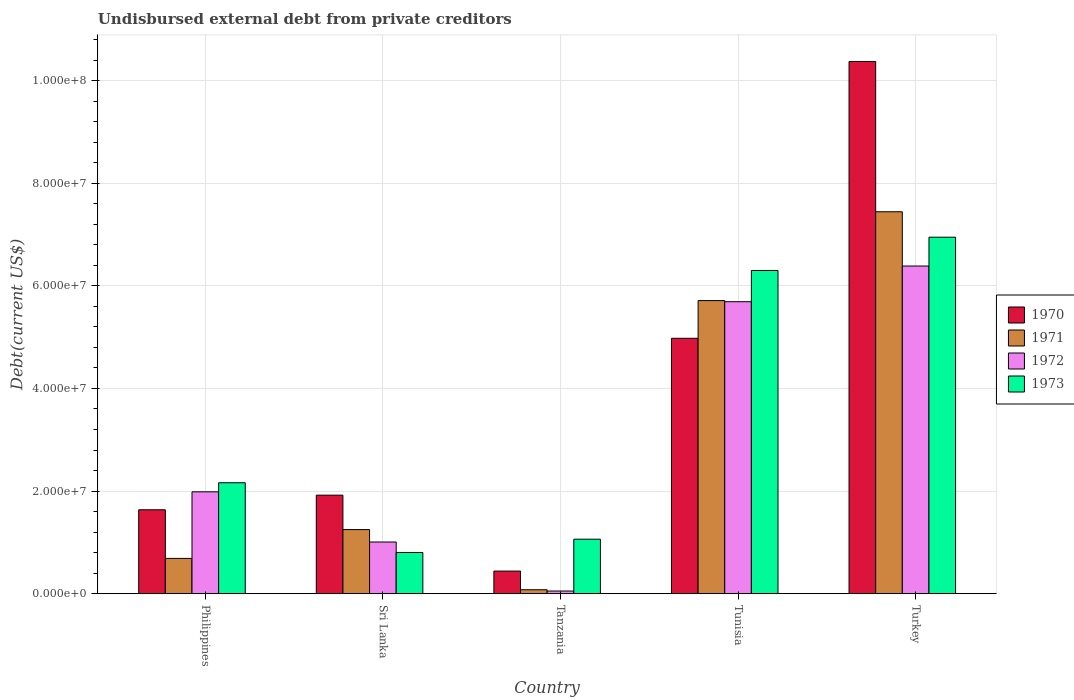How many different coloured bars are there?
Offer a terse response. 4. How many groups of bars are there?
Provide a short and direct response. 5. Are the number of bars per tick equal to the number of legend labels?
Your answer should be compact. Yes. What is the label of the 5th group of bars from the left?
Keep it short and to the point. Turkey. What is the total debt in 1971 in Tunisia?
Provide a succinct answer. 5.71e+07. Across all countries, what is the maximum total debt in 1971?
Your response must be concise. 7.44e+07. Across all countries, what is the minimum total debt in 1972?
Give a very brief answer. 5.15e+05. In which country was the total debt in 1973 minimum?
Your response must be concise. Sri Lanka. What is the total total debt in 1972 in the graph?
Keep it short and to the point. 1.51e+08. What is the difference between the total debt in 1972 in Tanzania and that in Turkey?
Ensure brevity in your answer.  -6.34e+07. What is the difference between the total debt in 1972 in Turkey and the total debt in 1971 in Sri Lanka?
Ensure brevity in your answer.  5.14e+07. What is the average total debt in 1972 per country?
Provide a short and direct response. 3.02e+07. What is the difference between the total debt of/in 1972 and total debt of/in 1970 in Tunisia?
Offer a very short reply. 7.13e+06. What is the ratio of the total debt in 1973 in Tanzania to that in Tunisia?
Make the answer very short. 0.17. Is the total debt in 1971 in Philippines less than that in Turkey?
Provide a succinct answer. Yes. Is the difference between the total debt in 1972 in Philippines and Sri Lanka greater than the difference between the total debt in 1970 in Philippines and Sri Lanka?
Your answer should be very brief. Yes. What is the difference between the highest and the second highest total debt in 1970?
Provide a succinct answer. 5.40e+07. What is the difference between the highest and the lowest total debt in 1971?
Provide a short and direct response. 7.37e+07. Is the sum of the total debt in 1972 in Sri Lanka and Tanzania greater than the maximum total debt in 1973 across all countries?
Make the answer very short. No. Is it the case that in every country, the sum of the total debt in 1973 and total debt in 1971 is greater than the sum of total debt in 1970 and total debt in 1972?
Ensure brevity in your answer.  No. What does the 1st bar from the left in Philippines represents?
Give a very brief answer. 1970. What does the 3rd bar from the right in Turkey represents?
Keep it short and to the point. 1971. Is it the case that in every country, the sum of the total debt in 1971 and total debt in 1970 is greater than the total debt in 1972?
Provide a short and direct response. Yes. Are the values on the major ticks of Y-axis written in scientific E-notation?
Provide a short and direct response. Yes. Does the graph contain grids?
Keep it short and to the point. Yes. How many legend labels are there?
Ensure brevity in your answer.  4. What is the title of the graph?
Offer a terse response. Undisbursed external debt from private creditors. What is the label or title of the Y-axis?
Your answer should be compact. Debt(current US$). What is the Debt(current US$) in 1970 in Philippines?
Your response must be concise. 1.64e+07. What is the Debt(current US$) in 1971 in Philippines?
Make the answer very short. 6.87e+06. What is the Debt(current US$) in 1972 in Philippines?
Your response must be concise. 1.99e+07. What is the Debt(current US$) of 1973 in Philippines?
Offer a very short reply. 2.16e+07. What is the Debt(current US$) in 1970 in Sri Lanka?
Ensure brevity in your answer.  1.92e+07. What is the Debt(current US$) in 1971 in Sri Lanka?
Offer a very short reply. 1.25e+07. What is the Debt(current US$) of 1972 in Sri Lanka?
Your response must be concise. 1.01e+07. What is the Debt(current US$) of 1973 in Sri Lanka?
Your response must be concise. 8.03e+06. What is the Debt(current US$) of 1970 in Tanzania?
Your response must be concise. 4.40e+06. What is the Debt(current US$) of 1971 in Tanzania?
Give a very brief answer. 7.65e+05. What is the Debt(current US$) of 1972 in Tanzania?
Provide a short and direct response. 5.15e+05. What is the Debt(current US$) of 1973 in Tanzania?
Give a very brief answer. 1.06e+07. What is the Debt(current US$) of 1970 in Tunisia?
Provide a short and direct response. 4.98e+07. What is the Debt(current US$) of 1971 in Tunisia?
Provide a succinct answer. 5.71e+07. What is the Debt(current US$) in 1972 in Tunisia?
Your answer should be very brief. 5.69e+07. What is the Debt(current US$) in 1973 in Tunisia?
Your answer should be compact. 6.30e+07. What is the Debt(current US$) of 1970 in Turkey?
Your response must be concise. 1.04e+08. What is the Debt(current US$) of 1971 in Turkey?
Provide a short and direct response. 7.44e+07. What is the Debt(current US$) of 1972 in Turkey?
Your answer should be compact. 6.39e+07. What is the Debt(current US$) in 1973 in Turkey?
Offer a terse response. 6.95e+07. Across all countries, what is the maximum Debt(current US$) in 1970?
Offer a terse response. 1.04e+08. Across all countries, what is the maximum Debt(current US$) of 1971?
Provide a succinct answer. 7.44e+07. Across all countries, what is the maximum Debt(current US$) of 1972?
Keep it short and to the point. 6.39e+07. Across all countries, what is the maximum Debt(current US$) of 1973?
Your answer should be very brief. 6.95e+07. Across all countries, what is the minimum Debt(current US$) in 1970?
Offer a terse response. 4.40e+06. Across all countries, what is the minimum Debt(current US$) of 1971?
Provide a succinct answer. 7.65e+05. Across all countries, what is the minimum Debt(current US$) of 1972?
Offer a terse response. 5.15e+05. Across all countries, what is the minimum Debt(current US$) in 1973?
Offer a very short reply. 8.03e+06. What is the total Debt(current US$) in 1970 in the graph?
Keep it short and to the point. 1.93e+08. What is the total Debt(current US$) of 1971 in the graph?
Your response must be concise. 1.52e+08. What is the total Debt(current US$) in 1972 in the graph?
Provide a succinct answer. 1.51e+08. What is the total Debt(current US$) in 1973 in the graph?
Your answer should be compact. 1.73e+08. What is the difference between the Debt(current US$) in 1970 in Philippines and that in Sri Lanka?
Make the answer very short. -2.85e+06. What is the difference between the Debt(current US$) in 1971 in Philippines and that in Sri Lanka?
Offer a terse response. -5.62e+06. What is the difference between the Debt(current US$) in 1972 in Philippines and that in Sri Lanka?
Offer a terse response. 9.78e+06. What is the difference between the Debt(current US$) of 1973 in Philippines and that in Sri Lanka?
Keep it short and to the point. 1.36e+07. What is the difference between the Debt(current US$) of 1970 in Philippines and that in Tanzania?
Provide a succinct answer. 1.20e+07. What is the difference between the Debt(current US$) of 1971 in Philippines and that in Tanzania?
Make the answer very short. 6.11e+06. What is the difference between the Debt(current US$) in 1972 in Philippines and that in Tanzania?
Provide a succinct answer. 1.93e+07. What is the difference between the Debt(current US$) of 1973 in Philippines and that in Tanzania?
Ensure brevity in your answer.  1.10e+07. What is the difference between the Debt(current US$) in 1970 in Philippines and that in Tunisia?
Offer a terse response. -3.34e+07. What is the difference between the Debt(current US$) in 1971 in Philippines and that in Tunisia?
Ensure brevity in your answer.  -5.03e+07. What is the difference between the Debt(current US$) in 1972 in Philippines and that in Tunisia?
Give a very brief answer. -3.71e+07. What is the difference between the Debt(current US$) of 1973 in Philippines and that in Tunisia?
Your answer should be very brief. -4.14e+07. What is the difference between the Debt(current US$) in 1970 in Philippines and that in Turkey?
Offer a very short reply. -8.74e+07. What is the difference between the Debt(current US$) of 1971 in Philippines and that in Turkey?
Your response must be concise. -6.76e+07. What is the difference between the Debt(current US$) of 1972 in Philippines and that in Turkey?
Offer a very short reply. -4.40e+07. What is the difference between the Debt(current US$) in 1973 in Philippines and that in Turkey?
Your answer should be very brief. -4.79e+07. What is the difference between the Debt(current US$) of 1970 in Sri Lanka and that in Tanzania?
Offer a very short reply. 1.48e+07. What is the difference between the Debt(current US$) of 1971 in Sri Lanka and that in Tanzania?
Make the answer very short. 1.17e+07. What is the difference between the Debt(current US$) of 1972 in Sri Lanka and that in Tanzania?
Offer a very short reply. 9.56e+06. What is the difference between the Debt(current US$) in 1973 in Sri Lanka and that in Tanzania?
Your answer should be compact. -2.59e+06. What is the difference between the Debt(current US$) of 1970 in Sri Lanka and that in Tunisia?
Ensure brevity in your answer.  -3.06e+07. What is the difference between the Debt(current US$) in 1971 in Sri Lanka and that in Tunisia?
Make the answer very short. -4.46e+07. What is the difference between the Debt(current US$) of 1972 in Sri Lanka and that in Tunisia?
Provide a short and direct response. -4.68e+07. What is the difference between the Debt(current US$) in 1973 in Sri Lanka and that in Tunisia?
Make the answer very short. -5.50e+07. What is the difference between the Debt(current US$) of 1970 in Sri Lanka and that in Turkey?
Your answer should be very brief. -8.45e+07. What is the difference between the Debt(current US$) of 1971 in Sri Lanka and that in Turkey?
Offer a very short reply. -6.20e+07. What is the difference between the Debt(current US$) of 1972 in Sri Lanka and that in Turkey?
Your answer should be very brief. -5.38e+07. What is the difference between the Debt(current US$) of 1973 in Sri Lanka and that in Turkey?
Your answer should be compact. -6.15e+07. What is the difference between the Debt(current US$) in 1970 in Tanzania and that in Tunisia?
Make the answer very short. -4.54e+07. What is the difference between the Debt(current US$) of 1971 in Tanzania and that in Tunisia?
Ensure brevity in your answer.  -5.64e+07. What is the difference between the Debt(current US$) of 1972 in Tanzania and that in Tunisia?
Your answer should be very brief. -5.64e+07. What is the difference between the Debt(current US$) in 1973 in Tanzania and that in Tunisia?
Your response must be concise. -5.24e+07. What is the difference between the Debt(current US$) of 1970 in Tanzania and that in Turkey?
Your answer should be compact. -9.93e+07. What is the difference between the Debt(current US$) in 1971 in Tanzania and that in Turkey?
Give a very brief answer. -7.37e+07. What is the difference between the Debt(current US$) of 1972 in Tanzania and that in Turkey?
Make the answer very short. -6.34e+07. What is the difference between the Debt(current US$) in 1973 in Tanzania and that in Turkey?
Give a very brief answer. -5.89e+07. What is the difference between the Debt(current US$) of 1970 in Tunisia and that in Turkey?
Keep it short and to the point. -5.40e+07. What is the difference between the Debt(current US$) in 1971 in Tunisia and that in Turkey?
Provide a short and direct response. -1.73e+07. What is the difference between the Debt(current US$) in 1972 in Tunisia and that in Turkey?
Your answer should be very brief. -6.96e+06. What is the difference between the Debt(current US$) in 1973 in Tunisia and that in Turkey?
Offer a very short reply. -6.49e+06. What is the difference between the Debt(current US$) of 1970 in Philippines and the Debt(current US$) of 1971 in Sri Lanka?
Provide a succinct answer. 3.86e+06. What is the difference between the Debt(current US$) in 1970 in Philippines and the Debt(current US$) in 1972 in Sri Lanka?
Provide a succinct answer. 6.28e+06. What is the difference between the Debt(current US$) in 1970 in Philippines and the Debt(current US$) in 1973 in Sri Lanka?
Ensure brevity in your answer.  8.32e+06. What is the difference between the Debt(current US$) of 1971 in Philippines and the Debt(current US$) of 1972 in Sri Lanka?
Your response must be concise. -3.20e+06. What is the difference between the Debt(current US$) in 1971 in Philippines and the Debt(current US$) in 1973 in Sri Lanka?
Offer a terse response. -1.16e+06. What is the difference between the Debt(current US$) of 1972 in Philippines and the Debt(current US$) of 1973 in Sri Lanka?
Your answer should be compact. 1.18e+07. What is the difference between the Debt(current US$) of 1970 in Philippines and the Debt(current US$) of 1971 in Tanzania?
Give a very brief answer. 1.56e+07. What is the difference between the Debt(current US$) of 1970 in Philippines and the Debt(current US$) of 1972 in Tanzania?
Provide a short and direct response. 1.58e+07. What is the difference between the Debt(current US$) of 1970 in Philippines and the Debt(current US$) of 1973 in Tanzania?
Your response must be concise. 5.74e+06. What is the difference between the Debt(current US$) in 1971 in Philippines and the Debt(current US$) in 1972 in Tanzania?
Your response must be concise. 6.36e+06. What is the difference between the Debt(current US$) of 1971 in Philippines and the Debt(current US$) of 1973 in Tanzania?
Offer a very short reply. -3.74e+06. What is the difference between the Debt(current US$) in 1972 in Philippines and the Debt(current US$) in 1973 in Tanzania?
Your response must be concise. 9.24e+06. What is the difference between the Debt(current US$) of 1970 in Philippines and the Debt(current US$) of 1971 in Tunisia?
Your answer should be very brief. -4.08e+07. What is the difference between the Debt(current US$) of 1970 in Philippines and the Debt(current US$) of 1972 in Tunisia?
Provide a short and direct response. -4.06e+07. What is the difference between the Debt(current US$) of 1970 in Philippines and the Debt(current US$) of 1973 in Tunisia?
Ensure brevity in your answer.  -4.66e+07. What is the difference between the Debt(current US$) of 1971 in Philippines and the Debt(current US$) of 1972 in Tunisia?
Keep it short and to the point. -5.00e+07. What is the difference between the Debt(current US$) of 1971 in Philippines and the Debt(current US$) of 1973 in Tunisia?
Offer a very short reply. -5.61e+07. What is the difference between the Debt(current US$) of 1972 in Philippines and the Debt(current US$) of 1973 in Tunisia?
Keep it short and to the point. -4.31e+07. What is the difference between the Debt(current US$) of 1970 in Philippines and the Debt(current US$) of 1971 in Turkey?
Make the answer very short. -5.81e+07. What is the difference between the Debt(current US$) in 1970 in Philippines and the Debt(current US$) in 1972 in Turkey?
Offer a very short reply. -4.75e+07. What is the difference between the Debt(current US$) of 1970 in Philippines and the Debt(current US$) of 1973 in Turkey?
Your response must be concise. -5.31e+07. What is the difference between the Debt(current US$) in 1971 in Philippines and the Debt(current US$) in 1972 in Turkey?
Give a very brief answer. -5.70e+07. What is the difference between the Debt(current US$) in 1971 in Philippines and the Debt(current US$) in 1973 in Turkey?
Offer a terse response. -6.26e+07. What is the difference between the Debt(current US$) of 1972 in Philippines and the Debt(current US$) of 1973 in Turkey?
Offer a very short reply. -4.96e+07. What is the difference between the Debt(current US$) in 1970 in Sri Lanka and the Debt(current US$) in 1971 in Tanzania?
Your response must be concise. 1.84e+07. What is the difference between the Debt(current US$) in 1970 in Sri Lanka and the Debt(current US$) in 1972 in Tanzania?
Provide a short and direct response. 1.87e+07. What is the difference between the Debt(current US$) in 1970 in Sri Lanka and the Debt(current US$) in 1973 in Tanzania?
Your answer should be very brief. 8.58e+06. What is the difference between the Debt(current US$) in 1971 in Sri Lanka and the Debt(current US$) in 1972 in Tanzania?
Ensure brevity in your answer.  1.20e+07. What is the difference between the Debt(current US$) in 1971 in Sri Lanka and the Debt(current US$) in 1973 in Tanzania?
Your response must be concise. 1.87e+06. What is the difference between the Debt(current US$) of 1972 in Sri Lanka and the Debt(current US$) of 1973 in Tanzania?
Provide a succinct answer. -5.46e+05. What is the difference between the Debt(current US$) of 1970 in Sri Lanka and the Debt(current US$) of 1971 in Tunisia?
Ensure brevity in your answer.  -3.79e+07. What is the difference between the Debt(current US$) in 1970 in Sri Lanka and the Debt(current US$) in 1972 in Tunisia?
Provide a succinct answer. -3.77e+07. What is the difference between the Debt(current US$) of 1970 in Sri Lanka and the Debt(current US$) of 1973 in Tunisia?
Provide a succinct answer. -4.38e+07. What is the difference between the Debt(current US$) of 1971 in Sri Lanka and the Debt(current US$) of 1972 in Tunisia?
Offer a terse response. -4.44e+07. What is the difference between the Debt(current US$) of 1971 in Sri Lanka and the Debt(current US$) of 1973 in Tunisia?
Your answer should be compact. -5.05e+07. What is the difference between the Debt(current US$) in 1972 in Sri Lanka and the Debt(current US$) in 1973 in Tunisia?
Offer a terse response. -5.29e+07. What is the difference between the Debt(current US$) in 1970 in Sri Lanka and the Debt(current US$) in 1971 in Turkey?
Give a very brief answer. -5.52e+07. What is the difference between the Debt(current US$) of 1970 in Sri Lanka and the Debt(current US$) of 1972 in Turkey?
Ensure brevity in your answer.  -4.47e+07. What is the difference between the Debt(current US$) in 1970 in Sri Lanka and the Debt(current US$) in 1973 in Turkey?
Give a very brief answer. -5.03e+07. What is the difference between the Debt(current US$) of 1971 in Sri Lanka and the Debt(current US$) of 1972 in Turkey?
Your response must be concise. -5.14e+07. What is the difference between the Debt(current US$) in 1971 in Sri Lanka and the Debt(current US$) in 1973 in Turkey?
Provide a short and direct response. -5.70e+07. What is the difference between the Debt(current US$) in 1972 in Sri Lanka and the Debt(current US$) in 1973 in Turkey?
Your answer should be very brief. -5.94e+07. What is the difference between the Debt(current US$) of 1970 in Tanzania and the Debt(current US$) of 1971 in Tunisia?
Provide a short and direct response. -5.27e+07. What is the difference between the Debt(current US$) of 1970 in Tanzania and the Debt(current US$) of 1972 in Tunisia?
Offer a terse response. -5.25e+07. What is the difference between the Debt(current US$) in 1970 in Tanzania and the Debt(current US$) in 1973 in Tunisia?
Offer a very short reply. -5.86e+07. What is the difference between the Debt(current US$) in 1971 in Tanzania and the Debt(current US$) in 1972 in Tunisia?
Keep it short and to the point. -5.61e+07. What is the difference between the Debt(current US$) of 1971 in Tanzania and the Debt(current US$) of 1973 in Tunisia?
Your response must be concise. -6.22e+07. What is the difference between the Debt(current US$) in 1972 in Tanzania and the Debt(current US$) in 1973 in Tunisia?
Keep it short and to the point. -6.25e+07. What is the difference between the Debt(current US$) of 1970 in Tanzania and the Debt(current US$) of 1971 in Turkey?
Your answer should be compact. -7.00e+07. What is the difference between the Debt(current US$) of 1970 in Tanzania and the Debt(current US$) of 1972 in Turkey?
Ensure brevity in your answer.  -5.95e+07. What is the difference between the Debt(current US$) of 1970 in Tanzania and the Debt(current US$) of 1973 in Turkey?
Ensure brevity in your answer.  -6.51e+07. What is the difference between the Debt(current US$) of 1971 in Tanzania and the Debt(current US$) of 1972 in Turkey?
Provide a short and direct response. -6.31e+07. What is the difference between the Debt(current US$) in 1971 in Tanzania and the Debt(current US$) in 1973 in Turkey?
Your answer should be compact. -6.87e+07. What is the difference between the Debt(current US$) in 1972 in Tanzania and the Debt(current US$) in 1973 in Turkey?
Provide a short and direct response. -6.90e+07. What is the difference between the Debt(current US$) in 1970 in Tunisia and the Debt(current US$) in 1971 in Turkey?
Your answer should be very brief. -2.47e+07. What is the difference between the Debt(current US$) in 1970 in Tunisia and the Debt(current US$) in 1972 in Turkey?
Give a very brief answer. -1.41e+07. What is the difference between the Debt(current US$) in 1970 in Tunisia and the Debt(current US$) in 1973 in Turkey?
Your answer should be very brief. -1.97e+07. What is the difference between the Debt(current US$) in 1971 in Tunisia and the Debt(current US$) in 1972 in Turkey?
Make the answer very short. -6.74e+06. What is the difference between the Debt(current US$) of 1971 in Tunisia and the Debt(current US$) of 1973 in Turkey?
Provide a short and direct response. -1.24e+07. What is the difference between the Debt(current US$) of 1972 in Tunisia and the Debt(current US$) of 1973 in Turkey?
Make the answer very short. -1.26e+07. What is the average Debt(current US$) of 1970 per country?
Your answer should be compact. 3.87e+07. What is the average Debt(current US$) in 1971 per country?
Your response must be concise. 3.03e+07. What is the average Debt(current US$) of 1972 per country?
Provide a succinct answer. 3.02e+07. What is the average Debt(current US$) of 1973 per country?
Offer a very short reply. 3.45e+07. What is the difference between the Debt(current US$) of 1970 and Debt(current US$) of 1971 in Philippines?
Give a very brief answer. 9.48e+06. What is the difference between the Debt(current US$) of 1970 and Debt(current US$) of 1972 in Philippines?
Offer a terse response. -3.50e+06. What is the difference between the Debt(current US$) in 1970 and Debt(current US$) in 1973 in Philippines?
Ensure brevity in your answer.  -5.27e+06. What is the difference between the Debt(current US$) in 1971 and Debt(current US$) in 1972 in Philippines?
Make the answer very short. -1.30e+07. What is the difference between the Debt(current US$) in 1971 and Debt(current US$) in 1973 in Philippines?
Make the answer very short. -1.47e+07. What is the difference between the Debt(current US$) of 1972 and Debt(current US$) of 1973 in Philippines?
Your answer should be very brief. -1.76e+06. What is the difference between the Debt(current US$) of 1970 and Debt(current US$) of 1971 in Sri Lanka?
Make the answer very short. 6.71e+06. What is the difference between the Debt(current US$) of 1970 and Debt(current US$) of 1972 in Sri Lanka?
Your answer should be very brief. 9.13e+06. What is the difference between the Debt(current US$) in 1970 and Debt(current US$) in 1973 in Sri Lanka?
Your response must be concise. 1.12e+07. What is the difference between the Debt(current US$) in 1971 and Debt(current US$) in 1972 in Sri Lanka?
Offer a terse response. 2.42e+06. What is the difference between the Debt(current US$) in 1971 and Debt(current US$) in 1973 in Sri Lanka?
Your answer should be very brief. 4.46e+06. What is the difference between the Debt(current US$) in 1972 and Debt(current US$) in 1973 in Sri Lanka?
Your answer should be compact. 2.04e+06. What is the difference between the Debt(current US$) in 1970 and Debt(current US$) in 1971 in Tanzania?
Provide a short and direct response. 3.64e+06. What is the difference between the Debt(current US$) of 1970 and Debt(current US$) of 1972 in Tanzania?
Ensure brevity in your answer.  3.88e+06. What is the difference between the Debt(current US$) in 1970 and Debt(current US$) in 1973 in Tanzania?
Provide a succinct answer. -6.22e+06. What is the difference between the Debt(current US$) of 1971 and Debt(current US$) of 1973 in Tanzania?
Provide a succinct answer. -9.85e+06. What is the difference between the Debt(current US$) of 1972 and Debt(current US$) of 1973 in Tanzania?
Provide a succinct answer. -1.01e+07. What is the difference between the Debt(current US$) in 1970 and Debt(current US$) in 1971 in Tunisia?
Your answer should be compact. -7.35e+06. What is the difference between the Debt(current US$) of 1970 and Debt(current US$) of 1972 in Tunisia?
Your answer should be compact. -7.13e+06. What is the difference between the Debt(current US$) in 1970 and Debt(current US$) in 1973 in Tunisia?
Ensure brevity in your answer.  -1.32e+07. What is the difference between the Debt(current US$) of 1971 and Debt(current US$) of 1972 in Tunisia?
Offer a very short reply. 2.17e+05. What is the difference between the Debt(current US$) of 1971 and Debt(current US$) of 1973 in Tunisia?
Offer a terse response. -5.87e+06. What is the difference between the Debt(current US$) in 1972 and Debt(current US$) in 1973 in Tunisia?
Offer a terse response. -6.08e+06. What is the difference between the Debt(current US$) of 1970 and Debt(current US$) of 1971 in Turkey?
Offer a very short reply. 2.93e+07. What is the difference between the Debt(current US$) in 1970 and Debt(current US$) in 1972 in Turkey?
Provide a succinct answer. 3.99e+07. What is the difference between the Debt(current US$) of 1970 and Debt(current US$) of 1973 in Turkey?
Ensure brevity in your answer.  3.43e+07. What is the difference between the Debt(current US$) in 1971 and Debt(current US$) in 1972 in Turkey?
Offer a very short reply. 1.06e+07. What is the difference between the Debt(current US$) in 1971 and Debt(current US$) in 1973 in Turkey?
Provide a short and direct response. 4.96e+06. What is the difference between the Debt(current US$) in 1972 and Debt(current US$) in 1973 in Turkey?
Keep it short and to the point. -5.62e+06. What is the ratio of the Debt(current US$) in 1970 in Philippines to that in Sri Lanka?
Give a very brief answer. 0.85. What is the ratio of the Debt(current US$) of 1971 in Philippines to that in Sri Lanka?
Provide a succinct answer. 0.55. What is the ratio of the Debt(current US$) of 1972 in Philippines to that in Sri Lanka?
Make the answer very short. 1.97. What is the ratio of the Debt(current US$) in 1973 in Philippines to that in Sri Lanka?
Your response must be concise. 2.69. What is the ratio of the Debt(current US$) in 1970 in Philippines to that in Tanzania?
Make the answer very short. 3.72. What is the ratio of the Debt(current US$) in 1971 in Philippines to that in Tanzania?
Ensure brevity in your answer.  8.98. What is the ratio of the Debt(current US$) in 1972 in Philippines to that in Tanzania?
Your answer should be very brief. 38.55. What is the ratio of the Debt(current US$) of 1973 in Philippines to that in Tanzania?
Make the answer very short. 2.04. What is the ratio of the Debt(current US$) in 1970 in Philippines to that in Tunisia?
Your answer should be very brief. 0.33. What is the ratio of the Debt(current US$) of 1971 in Philippines to that in Tunisia?
Give a very brief answer. 0.12. What is the ratio of the Debt(current US$) in 1972 in Philippines to that in Tunisia?
Your answer should be compact. 0.35. What is the ratio of the Debt(current US$) of 1973 in Philippines to that in Tunisia?
Provide a short and direct response. 0.34. What is the ratio of the Debt(current US$) of 1970 in Philippines to that in Turkey?
Give a very brief answer. 0.16. What is the ratio of the Debt(current US$) of 1971 in Philippines to that in Turkey?
Provide a succinct answer. 0.09. What is the ratio of the Debt(current US$) in 1972 in Philippines to that in Turkey?
Give a very brief answer. 0.31. What is the ratio of the Debt(current US$) in 1973 in Philippines to that in Turkey?
Provide a short and direct response. 0.31. What is the ratio of the Debt(current US$) of 1970 in Sri Lanka to that in Tanzania?
Offer a very short reply. 4.36. What is the ratio of the Debt(current US$) of 1971 in Sri Lanka to that in Tanzania?
Provide a succinct answer. 16.33. What is the ratio of the Debt(current US$) of 1972 in Sri Lanka to that in Tanzania?
Offer a terse response. 19.55. What is the ratio of the Debt(current US$) of 1973 in Sri Lanka to that in Tanzania?
Ensure brevity in your answer.  0.76. What is the ratio of the Debt(current US$) of 1970 in Sri Lanka to that in Tunisia?
Offer a terse response. 0.39. What is the ratio of the Debt(current US$) of 1971 in Sri Lanka to that in Tunisia?
Give a very brief answer. 0.22. What is the ratio of the Debt(current US$) of 1972 in Sri Lanka to that in Tunisia?
Your answer should be compact. 0.18. What is the ratio of the Debt(current US$) in 1973 in Sri Lanka to that in Tunisia?
Make the answer very short. 0.13. What is the ratio of the Debt(current US$) in 1970 in Sri Lanka to that in Turkey?
Offer a terse response. 0.19. What is the ratio of the Debt(current US$) of 1971 in Sri Lanka to that in Turkey?
Offer a terse response. 0.17. What is the ratio of the Debt(current US$) in 1972 in Sri Lanka to that in Turkey?
Provide a succinct answer. 0.16. What is the ratio of the Debt(current US$) of 1973 in Sri Lanka to that in Turkey?
Your answer should be very brief. 0.12. What is the ratio of the Debt(current US$) of 1970 in Tanzania to that in Tunisia?
Make the answer very short. 0.09. What is the ratio of the Debt(current US$) of 1971 in Tanzania to that in Tunisia?
Your answer should be very brief. 0.01. What is the ratio of the Debt(current US$) in 1972 in Tanzania to that in Tunisia?
Offer a very short reply. 0.01. What is the ratio of the Debt(current US$) in 1973 in Tanzania to that in Tunisia?
Your answer should be very brief. 0.17. What is the ratio of the Debt(current US$) in 1970 in Tanzania to that in Turkey?
Offer a very short reply. 0.04. What is the ratio of the Debt(current US$) in 1971 in Tanzania to that in Turkey?
Keep it short and to the point. 0.01. What is the ratio of the Debt(current US$) of 1972 in Tanzania to that in Turkey?
Offer a very short reply. 0.01. What is the ratio of the Debt(current US$) of 1973 in Tanzania to that in Turkey?
Your answer should be very brief. 0.15. What is the ratio of the Debt(current US$) in 1970 in Tunisia to that in Turkey?
Make the answer very short. 0.48. What is the ratio of the Debt(current US$) in 1971 in Tunisia to that in Turkey?
Offer a terse response. 0.77. What is the ratio of the Debt(current US$) in 1972 in Tunisia to that in Turkey?
Provide a short and direct response. 0.89. What is the ratio of the Debt(current US$) of 1973 in Tunisia to that in Turkey?
Offer a very short reply. 0.91. What is the difference between the highest and the second highest Debt(current US$) of 1970?
Provide a succinct answer. 5.40e+07. What is the difference between the highest and the second highest Debt(current US$) in 1971?
Provide a short and direct response. 1.73e+07. What is the difference between the highest and the second highest Debt(current US$) of 1972?
Keep it short and to the point. 6.96e+06. What is the difference between the highest and the second highest Debt(current US$) in 1973?
Make the answer very short. 6.49e+06. What is the difference between the highest and the lowest Debt(current US$) in 1970?
Offer a very short reply. 9.93e+07. What is the difference between the highest and the lowest Debt(current US$) in 1971?
Offer a very short reply. 7.37e+07. What is the difference between the highest and the lowest Debt(current US$) in 1972?
Offer a terse response. 6.34e+07. What is the difference between the highest and the lowest Debt(current US$) in 1973?
Offer a terse response. 6.15e+07. 